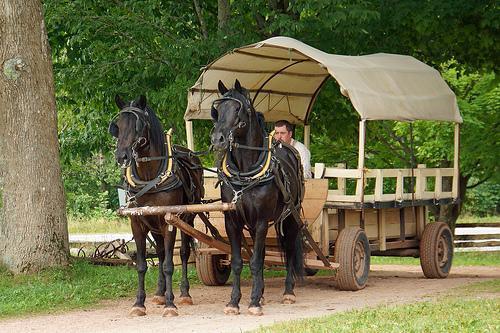How many horses are near a tree?
Give a very brief answer. 1. 